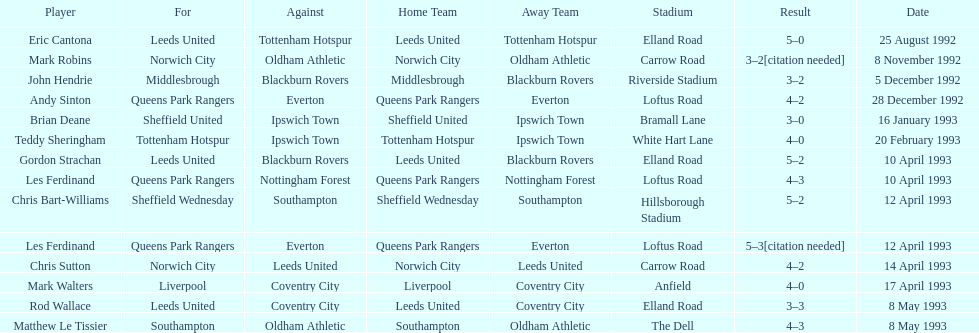Which player had the same result as mark robins? John Hendrie. 